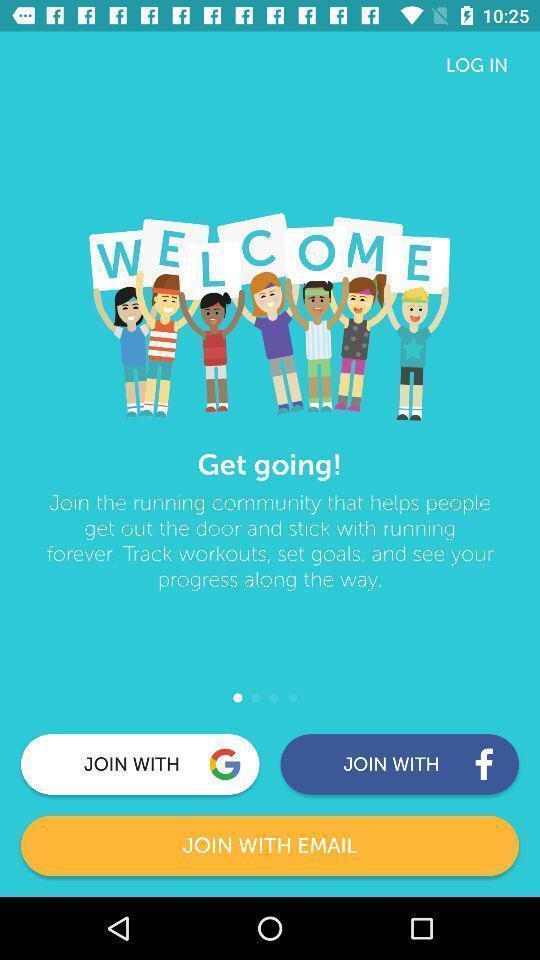Describe the key features of this screenshot. Welcome page of the fitness app. 